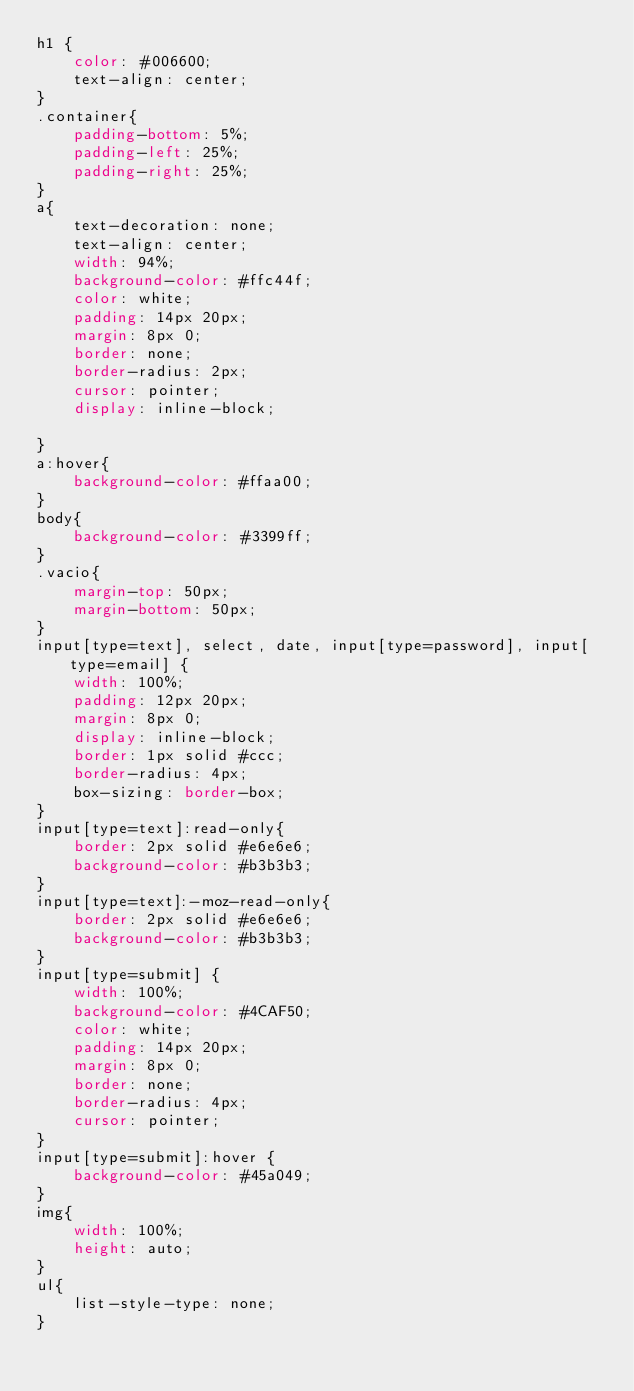<code> <loc_0><loc_0><loc_500><loc_500><_CSS_>h1 {
    color: #006600;
    text-align: center;
}
.container{
    padding-bottom: 5%;
    padding-left: 25%;
    padding-right: 25%;
}
a{
    text-decoration: none;
    text-align: center;
    width: 94%;
    background-color: #ffc44f;
    color: white;
    padding: 14px 20px;
    margin: 8px 0;
    border: none;
    border-radius: 2px;
    cursor: pointer;
    display: inline-block;
    
}
a:hover{
    background-color: #ffaa00;
}
body{
    background-color: #3399ff;
}
.vacio{
    margin-top: 50px;
    margin-bottom: 50px;
}
input[type=text], select, date, input[type=password], input[type=email] {
    width: 100%;
    padding: 12px 20px;
    margin: 8px 0;
    display: inline-block;
    border: 1px solid #ccc;
    border-radius: 4px;
    box-sizing: border-box;
}
input[type=text]:read-only{
    border: 2px solid #e6e6e6;
    background-color: #b3b3b3;
}
input[type=text]:-moz-read-only{
    border: 2px solid #e6e6e6;
    background-color: #b3b3b3;
}
input[type=submit] {
    width: 100%;
    background-color: #4CAF50;
    color: white;
    padding: 14px 20px;
    margin: 8px 0;
    border: none;
    border-radius: 4px;
    cursor: pointer;
}
input[type=submit]:hover {
    background-color: #45a049;
}
img{
    width: 100%;
    height: auto;
}
ul{
    list-style-type: none;
}</code> 